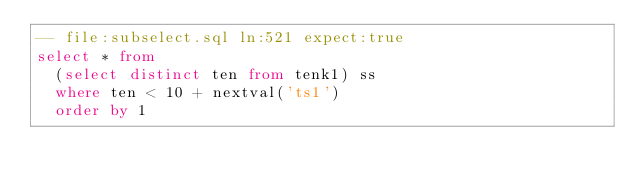<code> <loc_0><loc_0><loc_500><loc_500><_SQL_>-- file:subselect.sql ln:521 expect:true
select * from
  (select distinct ten from tenk1) ss
  where ten < 10 + nextval('ts1')
  order by 1
</code> 